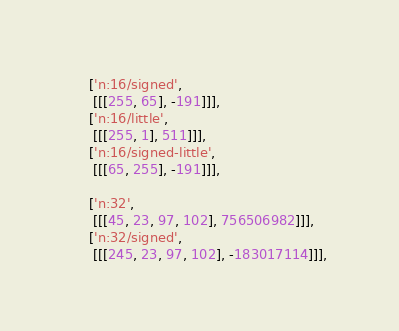<code> <loc_0><loc_0><loc_500><loc_500><_JavaScript_>    ['n:16/signed',
     [[[255, 65], -191]]],
    ['n:16/little',
     [[[255, 1], 511]]],
    ['n:16/signed-little',
     [[[65, 255], -191]]],

    ['n:32',
     [[[45, 23, 97, 102], 756506982]]],
    ['n:32/signed',
     [[[245, 23, 97, 102], -183017114]]],</code> 